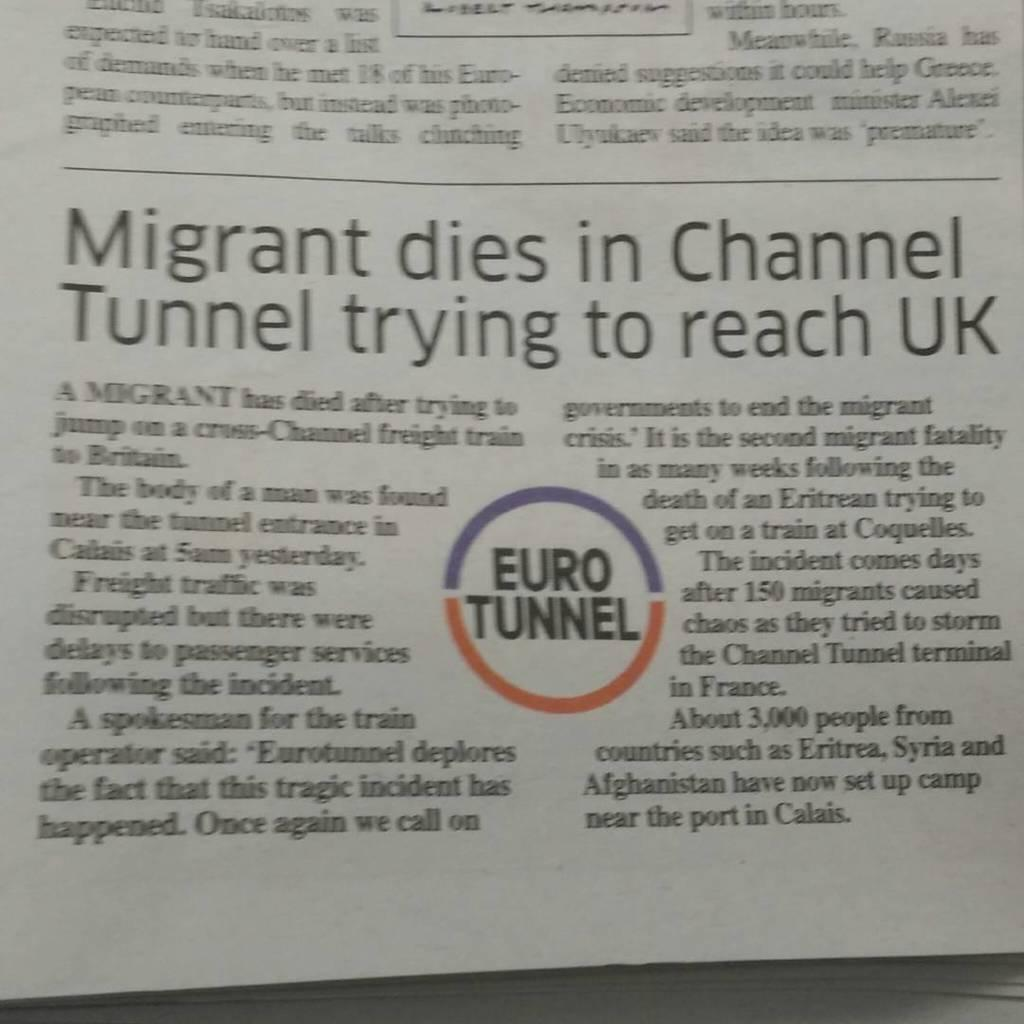<image>
Create a compact narrative representing the image presented. a page that has a circle on it that says 'euro tunnel' inside of it 